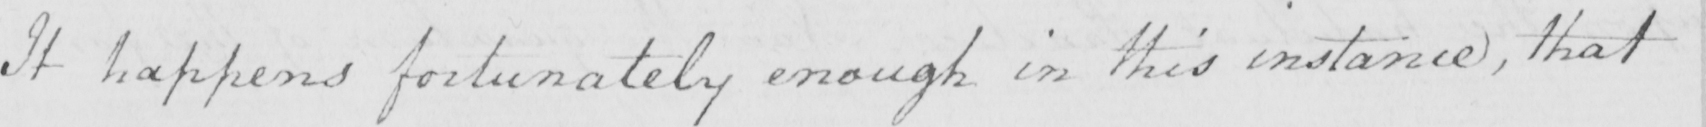Please transcribe the handwritten text in this image. It happens fortunately enough in this instance , that 